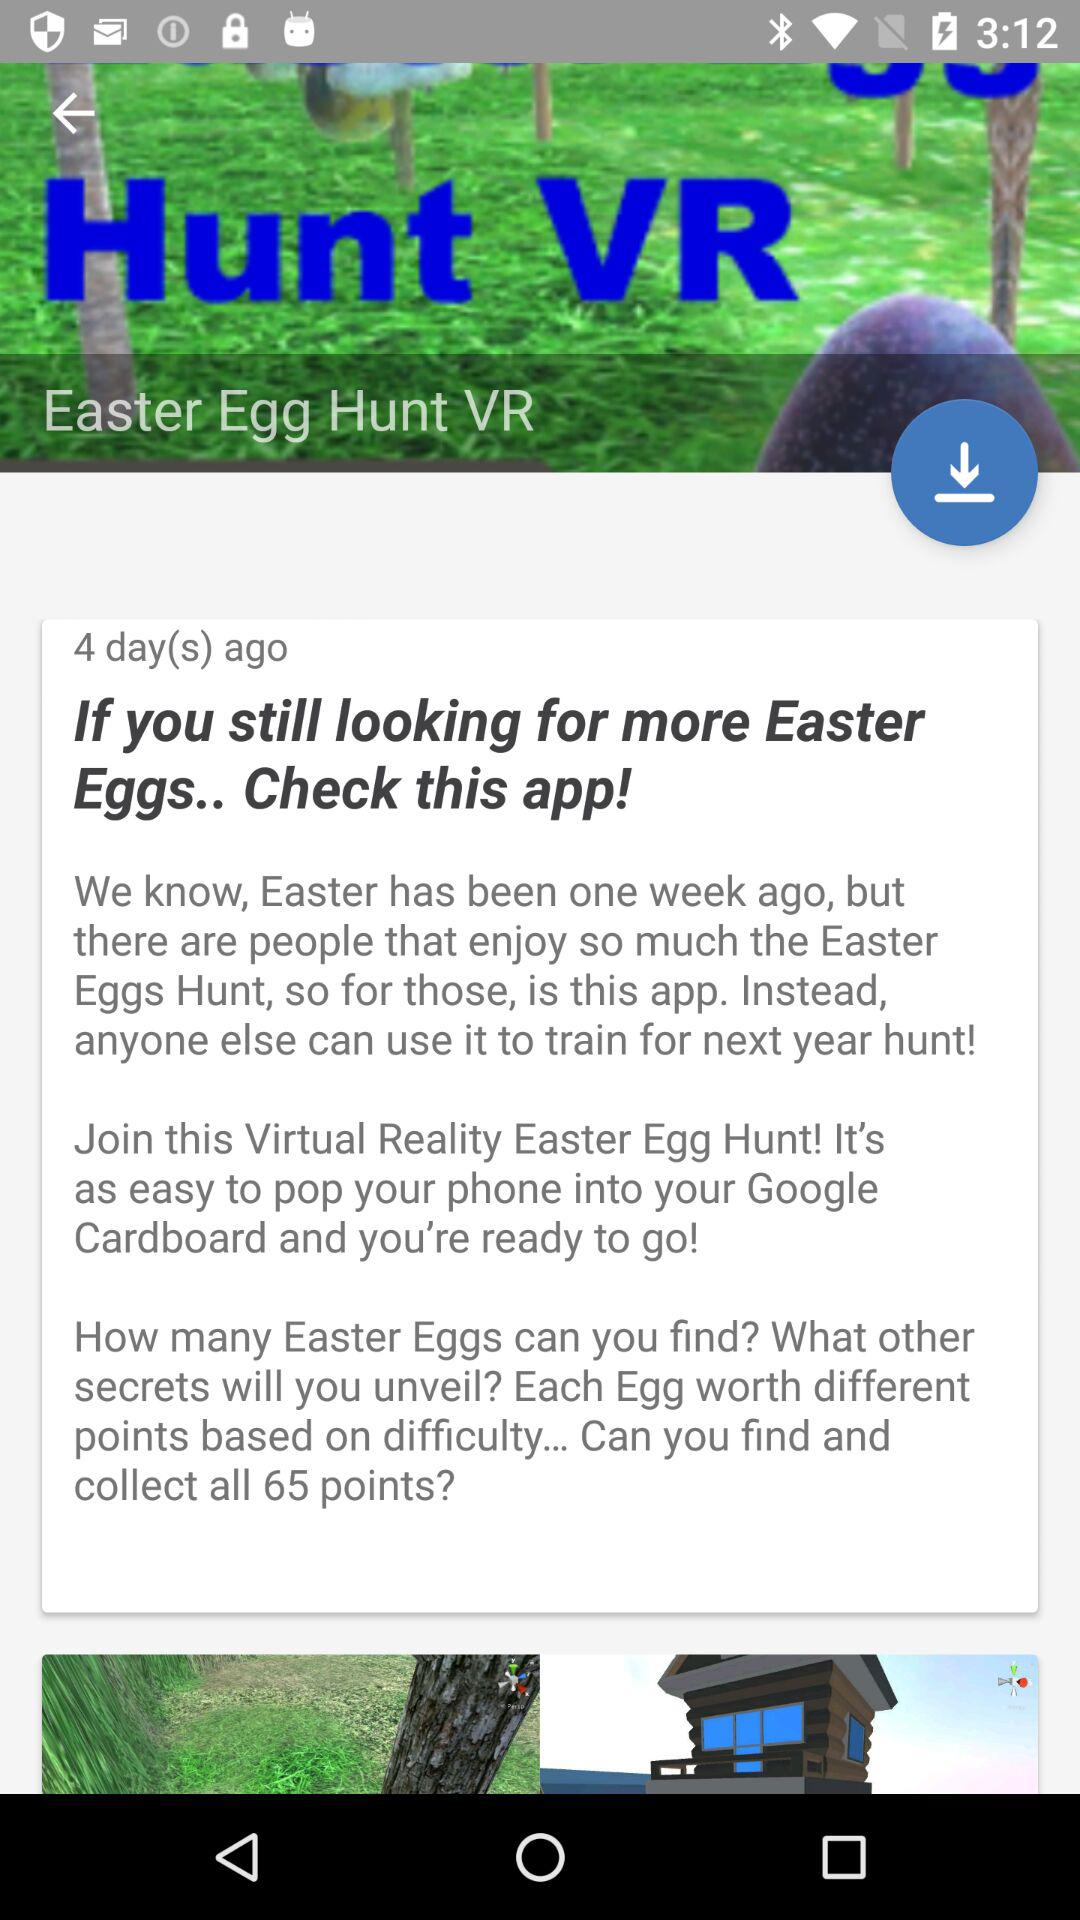How many Easter Eggs are there to find?
Answer the question using a single word or phrase. 65 